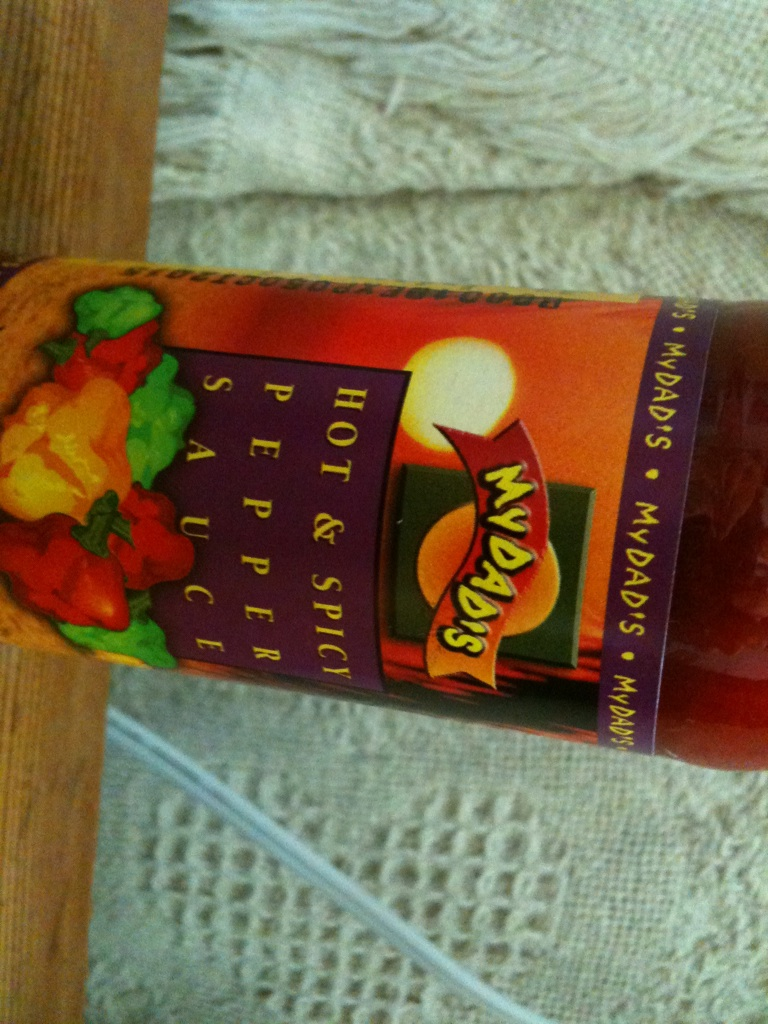What is this item? This is a bottle of pepper sauce, specifically a hot and spicy variant from the brand 'MYDAD'S'. Pepper sauce is commonly used to add heat and flavor to various dishes. 